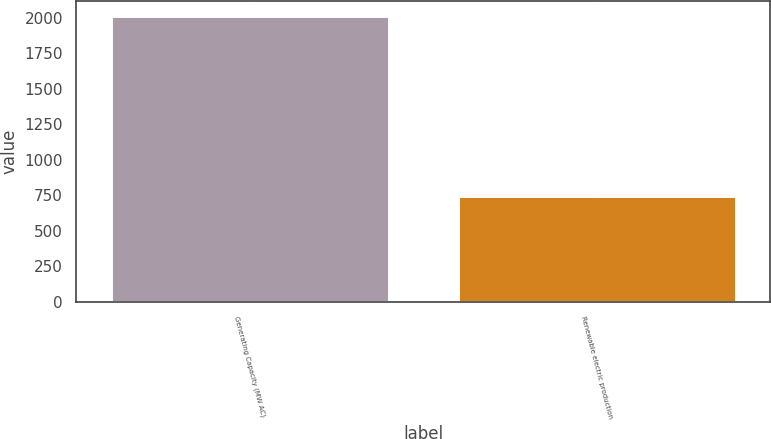Convert chart to OTSL. <chart><loc_0><loc_0><loc_500><loc_500><bar_chart><fcel>Generating Capacity (MW AC)<fcel>Renewable electric production<nl><fcel>2015<fcel>748<nl></chart> 